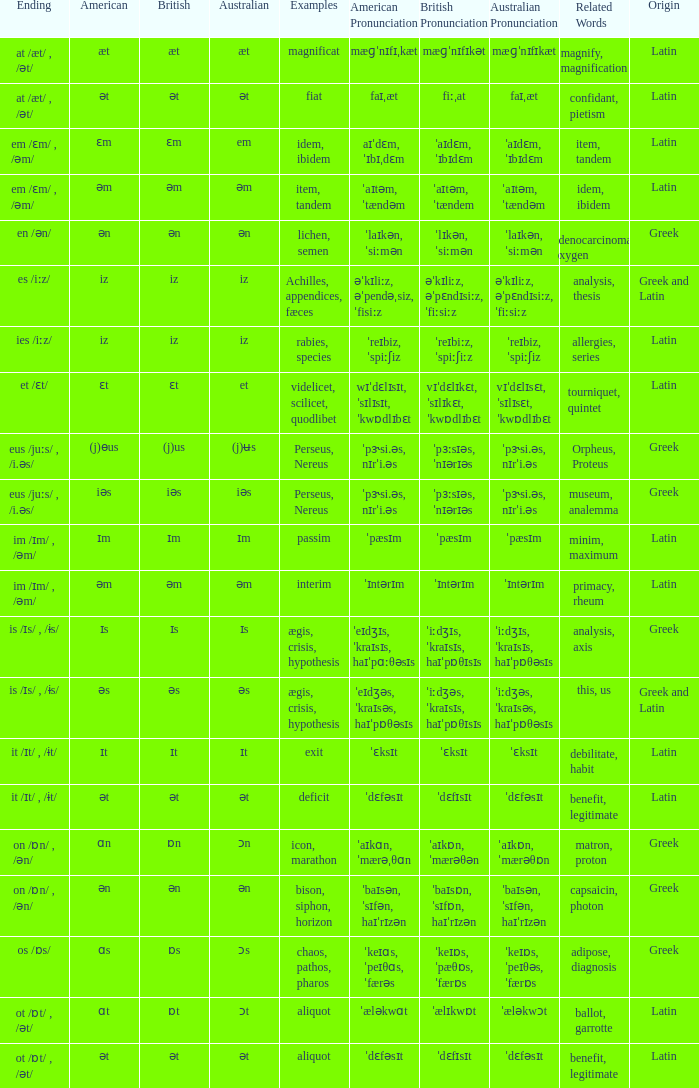Which Examples has Australian of əm? Item, tandem, interim. 